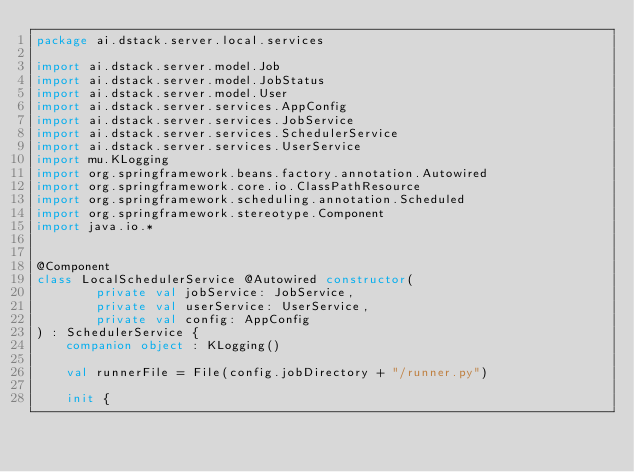Convert code to text. <code><loc_0><loc_0><loc_500><loc_500><_Kotlin_>package ai.dstack.server.local.services

import ai.dstack.server.model.Job
import ai.dstack.server.model.JobStatus
import ai.dstack.server.model.User
import ai.dstack.server.services.AppConfig
import ai.dstack.server.services.JobService
import ai.dstack.server.services.SchedulerService
import ai.dstack.server.services.UserService
import mu.KLogging
import org.springframework.beans.factory.annotation.Autowired
import org.springframework.core.io.ClassPathResource
import org.springframework.scheduling.annotation.Scheduled
import org.springframework.stereotype.Component
import java.io.*


@Component
class LocalSchedulerService @Autowired constructor(
        private val jobService: JobService,
        private val userService: UserService,
        private val config: AppConfig
) : SchedulerService {
    companion object : KLogging()

    val runnerFile = File(config.jobDirectory + "/runner.py")

    init {</code> 